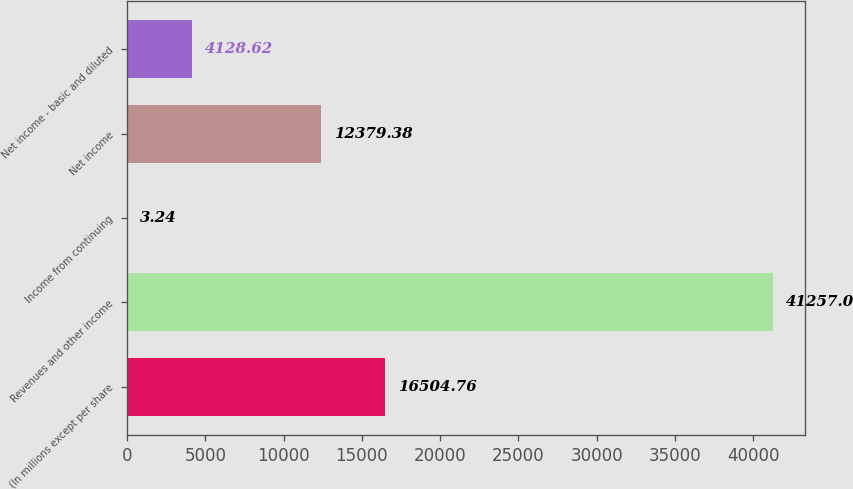Convert chart. <chart><loc_0><loc_0><loc_500><loc_500><bar_chart><fcel>(In millions except per share<fcel>Revenues and other income<fcel>Income from continuing<fcel>Net income<fcel>Net income - basic and diluted<nl><fcel>16504.8<fcel>41257<fcel>3.24<fcel>12379.4<fcel>4128.62<nl></chart> 